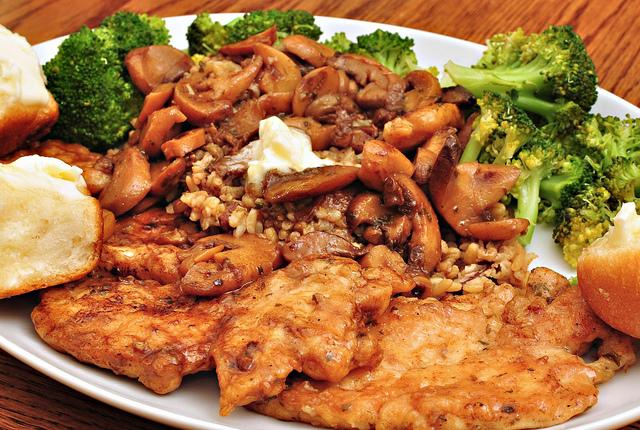Has the meal been cooked?
Keep it brief. Yes. Is there sauce on the plate?
Quick response, please. No. What is the green vegetable?
Write a very short answer. Broccoli. 